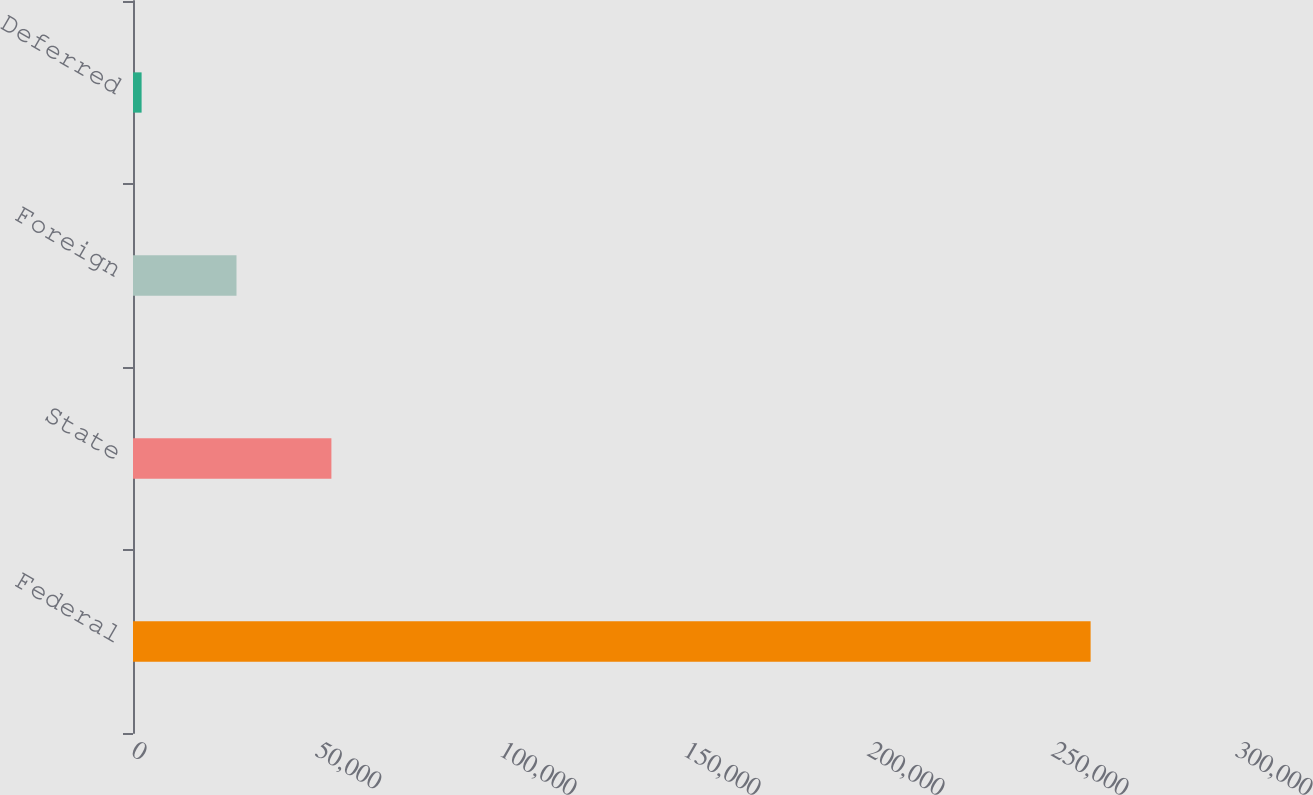Convert chart to OTSL. <chart><loc_0><loc_0><loc_500><loc_500><bar_chart><fcel>Federal<fcel>State<fcel>Foreign<fcel>Deferred<nl><fcel>260222<fcel>53914<fcel>28125.5<fcel>2337<nl></chart> 